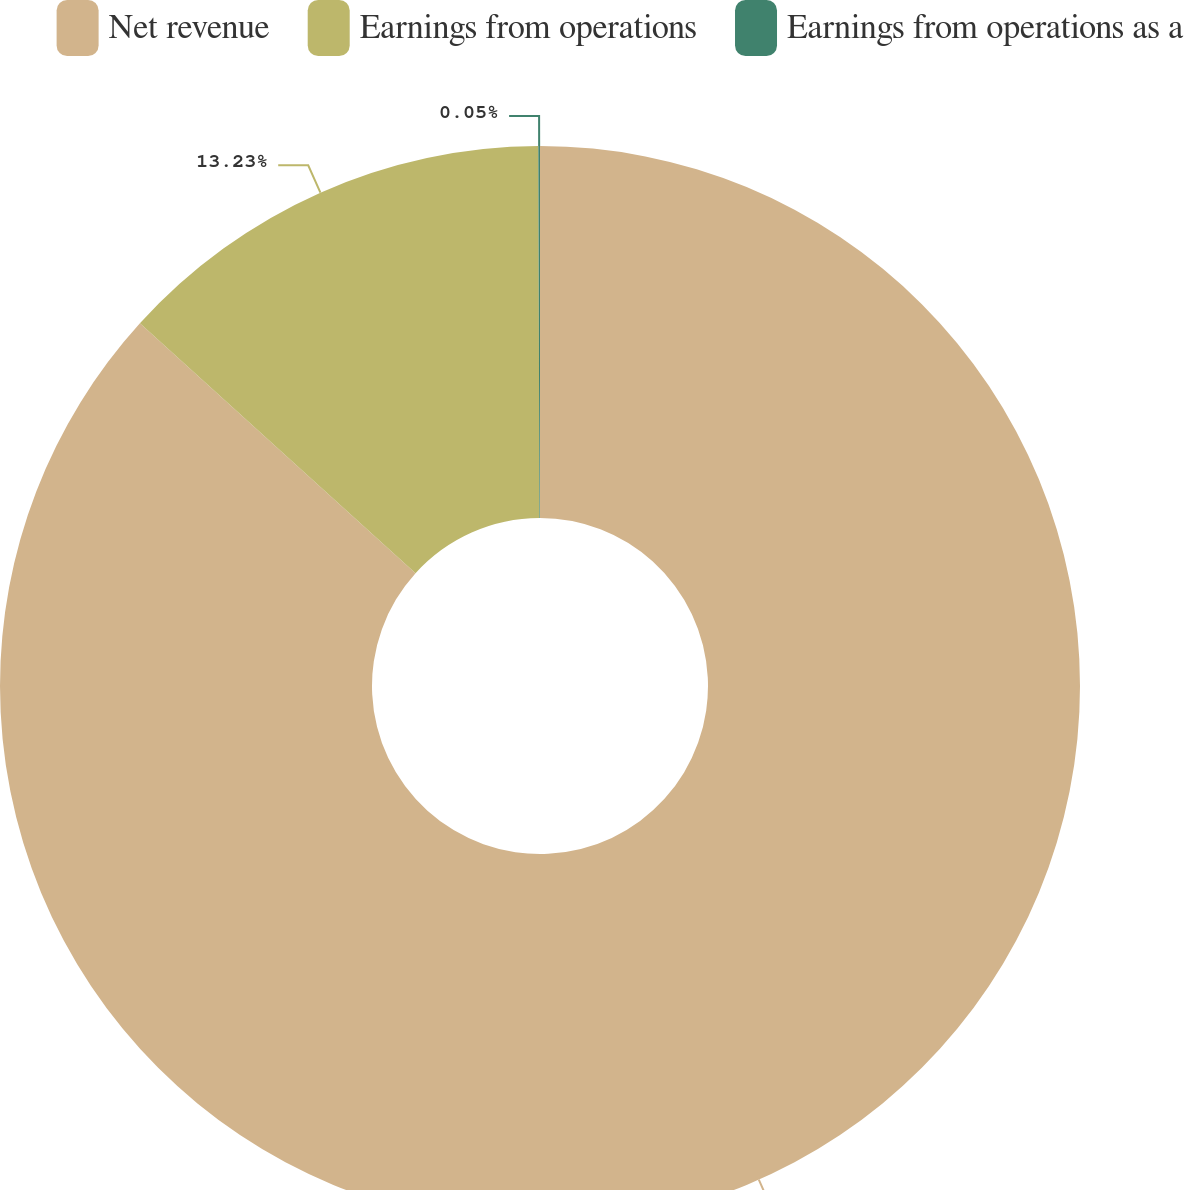Convert chart to OTSL. <chart><loc_0><loc_0><loc_500><loc_500><pie_chart><fcel>Net revenue<fcel>Earnings from operations<fcel>Earnings from operations as a<nl><fcel>86.72%<fcel>13.23%<fcel>0.05%<nl></chart> 